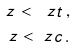<formula> <loc_0><loc_0><loc_500><loc_500>\ z < \ z t \, , \\ \ z < \ z c \, .</formula> 